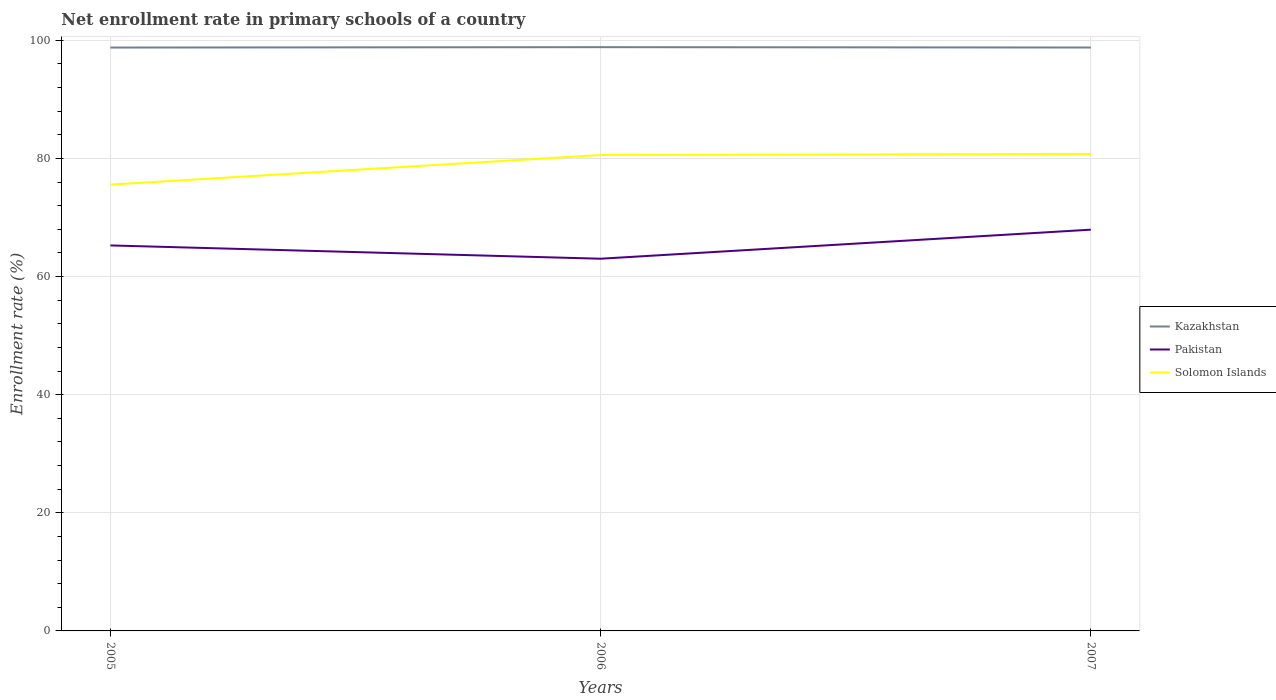How many different coloured lines are there?
Offer a very short reply. 3. Across all years, what is the maximum enrollment rate in primary schools in Pakistan?
Give a very brief answer. 63.01. What is the total enrollment rate in primary schools in Kazakhstan in the graph?
Your answer should be compact. -0.07. What is the difference between the highest and the second highest enrollment rate in primary schools in Pakistan?
Your response must be concise. 4.92. Is the enrollment rate in primary schools in Kazakhstan strictly greater than the enrollment rate in primary schools in Solomon Islands over the years?
Your answer should be compact. No. How many years are there in the graph?
Provide a succinct answer. 3. Does the graph contain grids?
Offer a terse response. Yes. How many legend labels are there?
Offer a very short reply. 3. How are the legend labels stacked?
Offer a very short reply. Vertical. What is the title of the graph?
Ensure brevity in your answer.  Net enrollment rate in primary schools of a country. Does "Mongolia" appear as one of the legend labels in the graph?
Your answer should be very brief. No. What is the label or title of the X-axis?
Keep it short and to the point. Years. What is the label or title of the Y-axis?
Keep it short and to the point. Enrollment rate (%). What is the Enrollment rate (%) in Kazakhstan in 2005?
Give a very brief answer. 98.76. What is the Enrollment rate (%) of Pakistan in 2005?
Your answer should be very brief. 65.26. What is the Enrollment rate (%) of Solomon Islands in 2005?
Your answer should be compact. 75.56. What is the Enrollment rate (%) of Kazakhstan in 2006?
Provide a succinct answer. 98.83. What is the Enrollment rate (%) of Pakistan in 2006?
Give a very brief answer. 63.01. What is the Enrollment rate (%) in Solomon Islands in 2006?
Your answer should be compact. 80.57. What is the Enrollment rate (%) in Kazakhstan in 2007?
Your response must be concise. 98.77. What is the Enrollment rate (%) of Pakistan in 2007?
Make the answer very short. 67.93. What is the Enrollment rate (%) of Solomon Islands in 2007?
Your answer should be very brief. 80.74. Across all years, what is the maximum Enrollment rate (%) in Kazakhstan?
Your answer should be compact. 98.83. Across all years, what is the maximum Enrollment rate (%) in Pakistan?
Provide a short and direct response. 67.93. Across all years, what is the maximum Enrollment rate (%) in Solomon Islands?
Provide a succinct answer. 80.74. Across all years, what is the minimum Enrollment rate (%) in Kazakhstan?
Ensure brevity in your answer.  98.76. Across all years, what is the minimum Enrollment rate (%) in Pakistan?
Your response must be concise. 63.01. Across all years, what is the minimum Enrollment rate (%) of Solomon Islands?
Make the answer very short. 75.56. What is the total Enrollment rate (%) of Kazakhstan in the graph?
Your response must be concise. 296.36. What is the total Enrollment rate (%) of Pakistan in the graph?
Keep it short and to the point. 196.21. What is the total Enrollment rate (%) of Solomon Islands in the graph?
Give a very brief answer. 236.87. What is the difference between the Enrollment rate (%) in Kazakhstan in 2005 and that in 2006?
Offer a terse response. -0.07. What is the difference between the Enrollment rate (%) in Pakistan in 2005 and that in 2006?
Offer a terse response. 2.25. What is the difference between the Enrollment rate (%) of Solomon Islands in 2005 and that in 2006?
Your response must be concise. -5.01. What is the difference between the Enrollment rate (%) of Kazakhstan in 2005 and that in 2007?
Your answer should be very brief. -0.01. What is the difference between the Enrollment rate (%) of Pakistan in 2005 and that in 2007?
Your answer should be compact. -2.67. What is the difference between the Enrollment rate (%) of Solomon Islands in 2005 and that in 2007?
Provide a short and direct response. -5.18. What is the difference between the Enrollment rate (%) of Kazakhstan in 2006 and that in 2007?
Make the answer very short. 0.06. What is the difference between the Enrollment rate (%) of Pakistan in 2006 and that in 2007?
Give a very brief answer. -4.92. What is the difference between the Enrollment rate (%) of Solomon Islands in 2006 and that in 2007?
Your answer should be very brief. -0.17. What is the difference between the Enrollment rate (%) of Kazakhstan in 2005 and the Enrollment rate (%) of Pakistan in 2006?
Your answer should be very brief. 35.75. What is the difference between the Enrollment rate (%) of Kazakhstan in 2005 and the Enrollment rate (%) of Solomon Islands in 2006?
Keep it short and to the point. 18.2. What is the difference between the Enrollment rate (%) of Pakistan in 2005 and the Enrollment rate (%) of Solomon Islands in 2006?
Offer a terse response. -15.3. What is the difference between the Enrollment rate (%) of Kazakhstan in 2005 and the Enrollment rate (%) of Pakistan in 2007?
Give a very brief answer. 30.83. What is the difference between the Enrollment rate (%) in Kazakhstan in 2005 and the Enrollment rate (%) in Solomon Islands in 2007?
Offer a very short reply. 18.02. What is the difference between the Enrollment rate (%) in Pakistan in 2005 and the Enrollment rate (%) in Solomon Islands in 2007?
Ensure brevity in your answer.  -15.48. What is the difference between the Enrollment rate (%) in Kazakhstan in 2006 and the Enrollment rate (%) in Pakistan in 2007?
Your answer should be compact. 30.9. What is the difference between the Enrollment rate (%) of Kazakhstan in 2006 and the Enrollment rate (%) of Solomon Islands in 2007?
Give a very brief answer. 18.09. What is the difference between the Enrollment rate (%) of Pakistan in 2006 and the Enrollment rate (%) of Solomon Islands in 2007?
Provide a short and direct response. -17.73. What is the average Enrollment rate (%) in Kazakhstan per year?
Keep it short and to the point. 98.79. What is the average Enrollment rate (%) of Pakistan per year?
Give a very brief answer. 65.4. What is the average Enrollment rate (%) of Solomon Islands per year?
Your answer should be very brief. 78.96. In the year 2005, what is the difference between the Enrollment rate (%) of Kazakhstan and Enrollment rate (%) of Pakistan?
Ensure brevity in your answer.  33.5. In the year 2005, what is the difference between the Enrollment rate (%) of Kazakhstan and Enrollment rate (%) of Solomon Islands?
Provide a succinct answer. 23.2. In the year 2005, what is the difference between the Enrollment rate (%) of Pakistan and Enrollment rate (%) of Solomon Islands?
Your answer should be very brief. -10.3. In the year 2006, what is the difference between the Enrollment rate (%) in Kazakhstan and Enrollment rate (%) in Pakistan?
Provide a succinct answer. 35.82. In the year 2006, what is the difference between the Enrollment rate (%) of Kazakhstan and Enrollment rate (%) of Solomon Islands?
Your answer should be compact. 18.26. In the year 2006, what is the difference between the Enrollment rate (%) of Pakistan and Enrollment rate (%) of Solomon Islands?
Give a very brief answer. -17.55. In the year 2007, what is the difference between the Enrollment rate (%) in Kazakhstan and Enrollment rate (%) in Pakistan?
Keep it short and to the point. 30.84. In the year 2007, what is the difference between the Enrollment rate (%) in Kazakhstan and Enrollment rate (%) in Solomon Islands?
Your answer should be very brief. 18.03. In the year 2007, what is the difference between the Enrollment rate (%) of Pakistan and Enrollment rate (%) of Solomon Islands?
Provide a short and direct response. -12.81. What is the ratio of the Enrollment rate (%) of Kazakhstan in 2005 to that in 2006?
Offer a very short reply. 1. What is the ratio of the Enrollment rate (%) of Pakistan in 2005 to that in 2006?
Your response must be concise. 1.04. What is the ratio of the Enrollment rate (%) of Solomon Islands in 2005 to that in 2006?
Offer a very short reply. 0.94. What is the ratio of the Enrollment rate (%) of Kazakhstan in 2005 to that in 2007?
Your answer should be very brief. 1. What is the ratio of the Enrollment rate (%) in Pakistan in 2005 to that in 2007?
Ensure brevity in your answer.  0.96. What is the ratio of the Enrollment rate (%) in Solomon Islands in 2005 to that in 2007?
Provide a short and direct response. 0.94. What is the ratio of the Enrollment rate (%) of Kazakhstan in 2006 to that in 2007?
Provide a succinct answer. 1. What is the ratio of the Enrollment rate (%) in Pakistan in 2006 to that in 2007?
Give a very brief answer. 0.93. What is the ratio of the Enrollment rate (%) of Solomon Islands in 2006 to that in 2007?
Provide a succinct answer. 1. What is the difference between the highest and the second highest Enrollment rate (%) of Kazakhstan?
Offer a terse response. 0.06. What is the difference between the highest and the second highest Enrollment rate (%) of Pakistan?
Make the answer very short. 2.67. What is the difference between the highest and the second highest Enrollment rate (%) in Solomon Islands?
Give a very brief answer. 0.17. What is the difference between the highest and the lowest Enrollment rate (%) in Kazakhstan?
Make the answer very short. 0.07. What is the difference between the highest and the lowest Enrollment rate (%) in Pakistan?
Ensure brevity in your answer.  4.92. What is the difference between the highest and the lowest Enrollment rate (%) of Solomon Islands?
Offer a terse response. 5.18. 